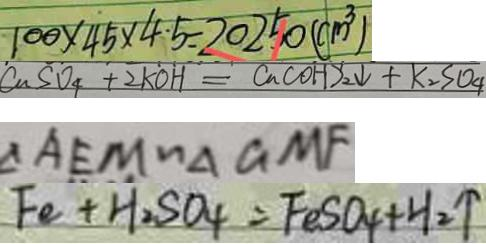Convert formula to latex. <formula><loc_0><loc_0><loc_500><loc_500>1 0 0 \times 4 5 \times 4 \cdot 5 = 2 0 2 5 0 ( c m ^ { 3 } ) 
 C u S O _ { 4 } + 2 K O H = C u ( O H ) _ { 2 } \downarrow + K _ { 2 } S O _ { 4 } 
 \Delta A E M \sim \Delta G M F 
 F e + H _ { 2 } S O _ { 4 } = F e S O _ { 4 } + H _ { 2 } \uparrow</formula> 